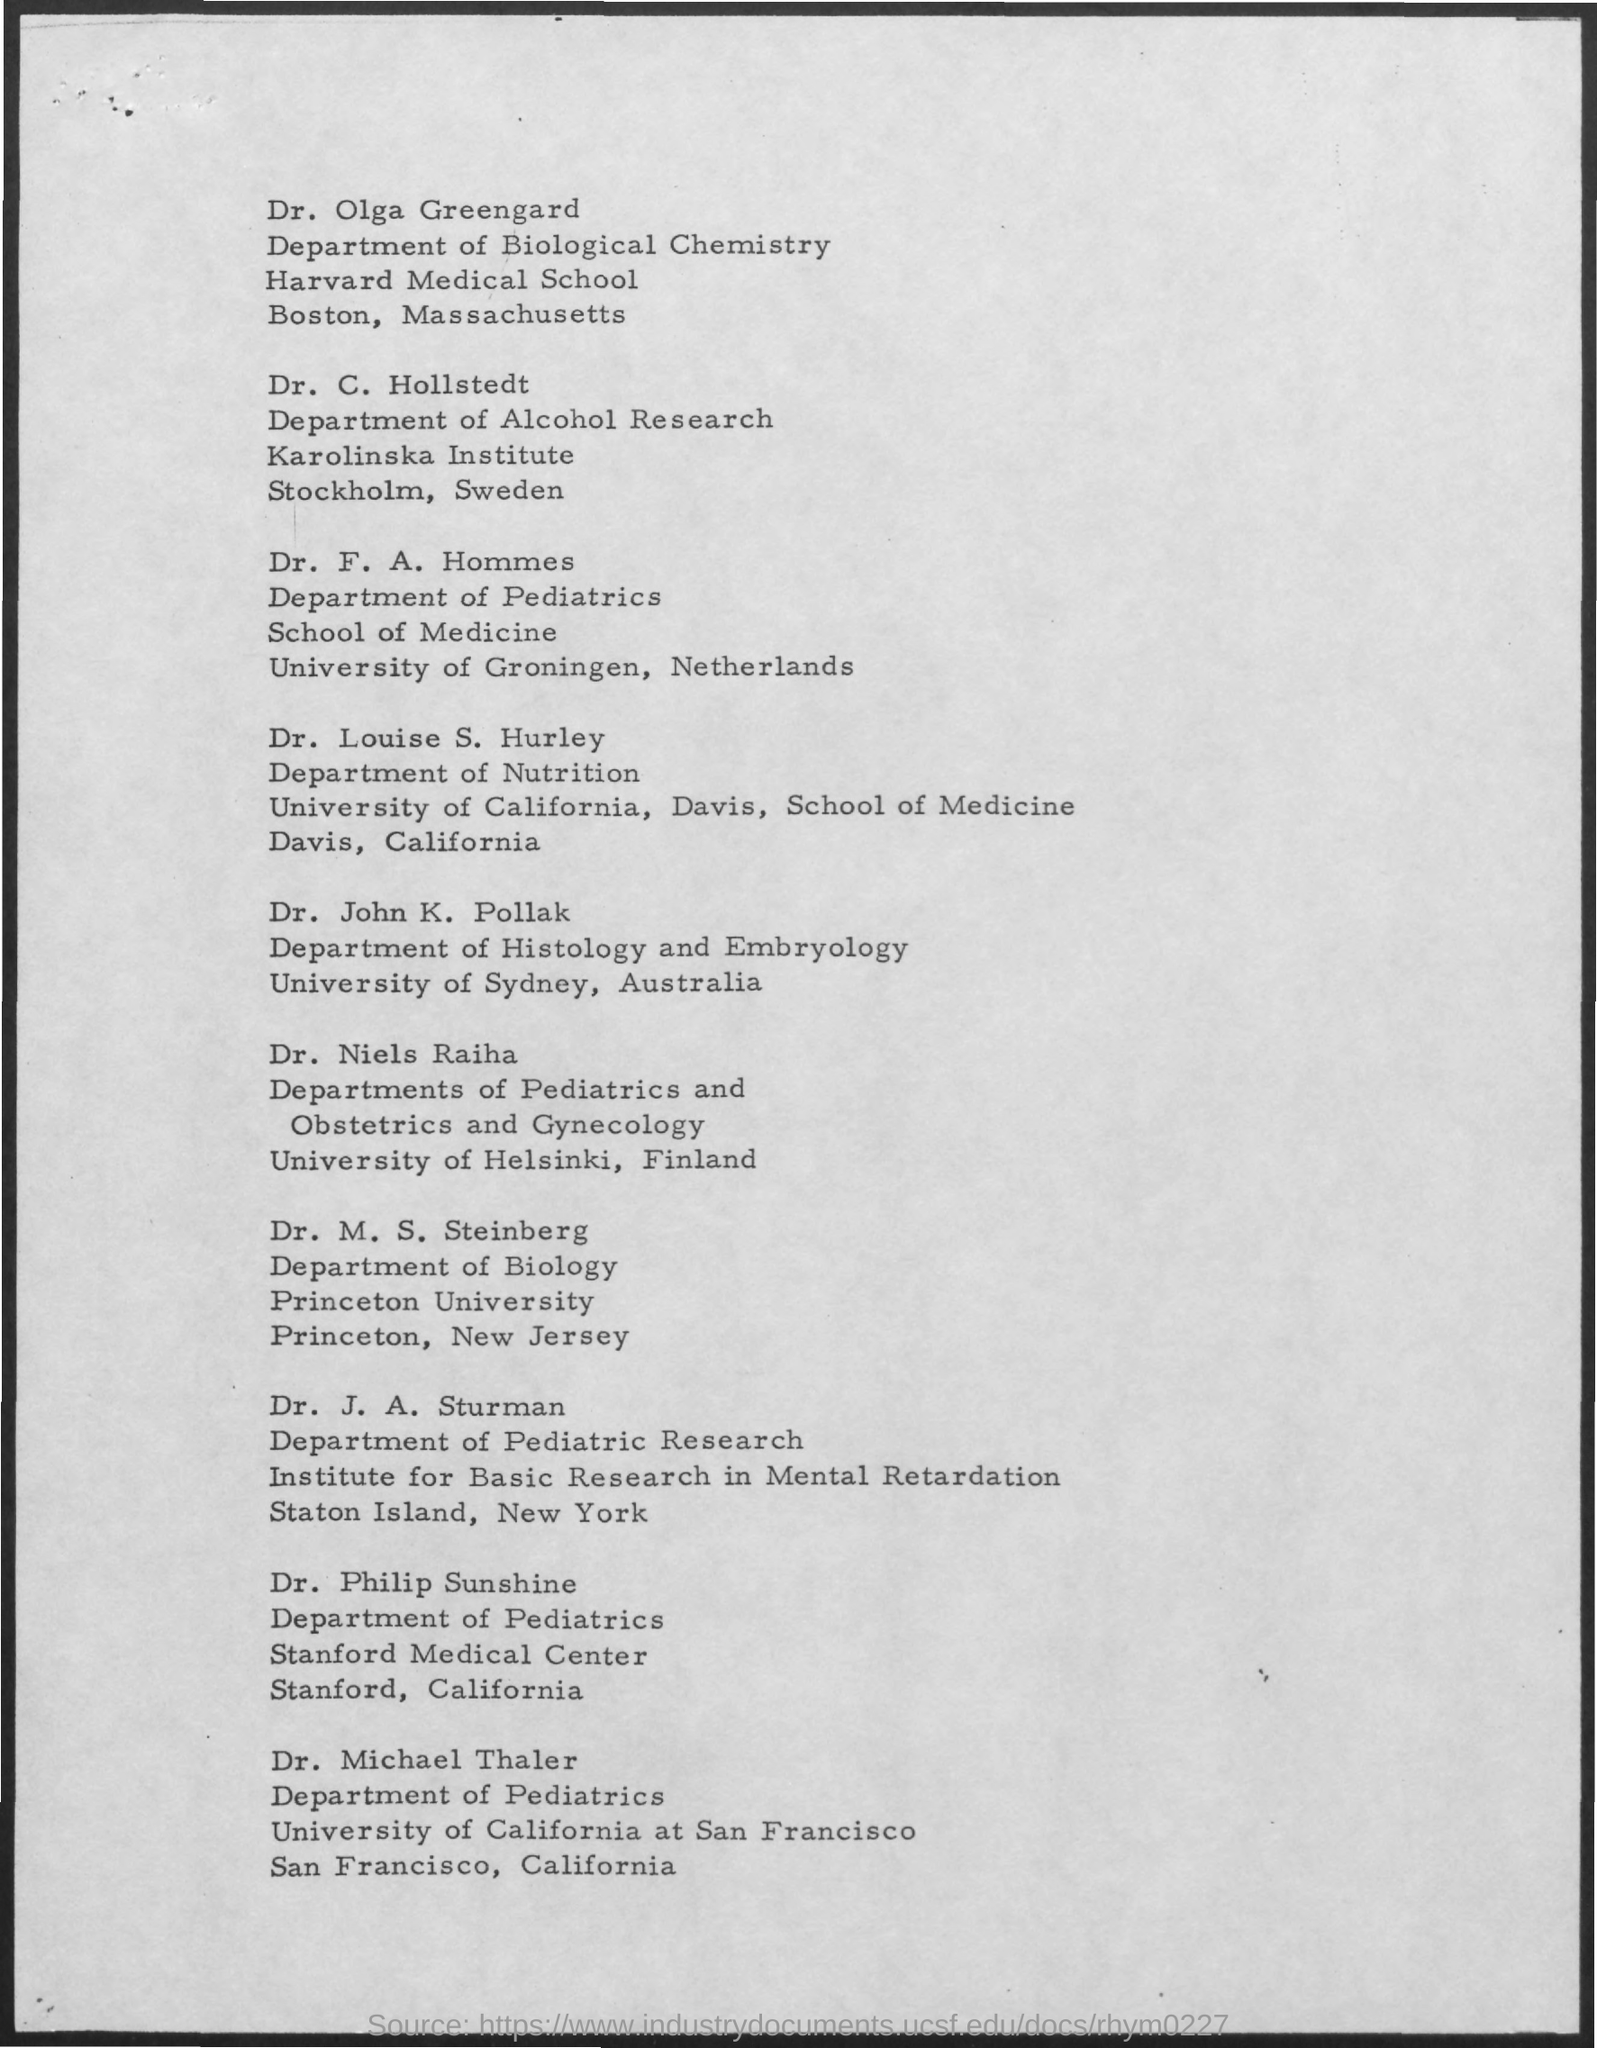Identify some key points in this picture. Dr. Olga Greengard is a member of the Department of Biological Chemistry. The University of Helsinki is located in Finland. 